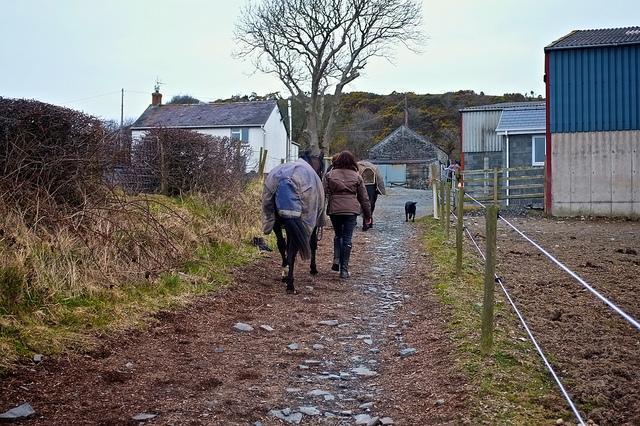How many people are there?
Give a very brief answer. 1. How many polo bears are in the image?
Give a very brief answer. 0. 